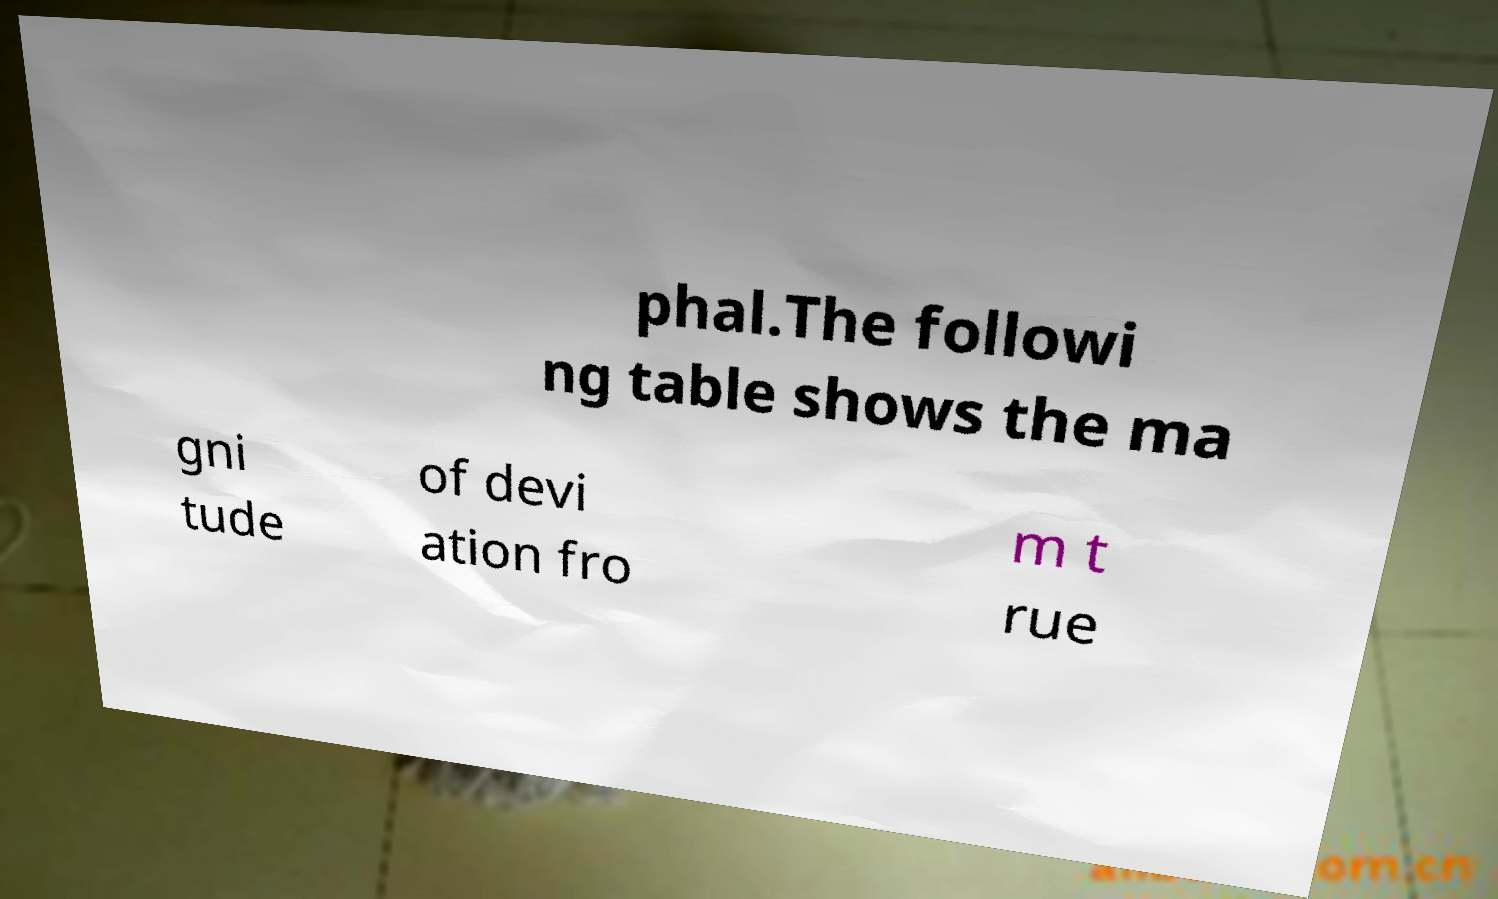There's text embedded in this image that I need extracted. Can you transcribe it verbatim? phal.The followi ng table shows the ma gni tude of devi ation fro m t rue 